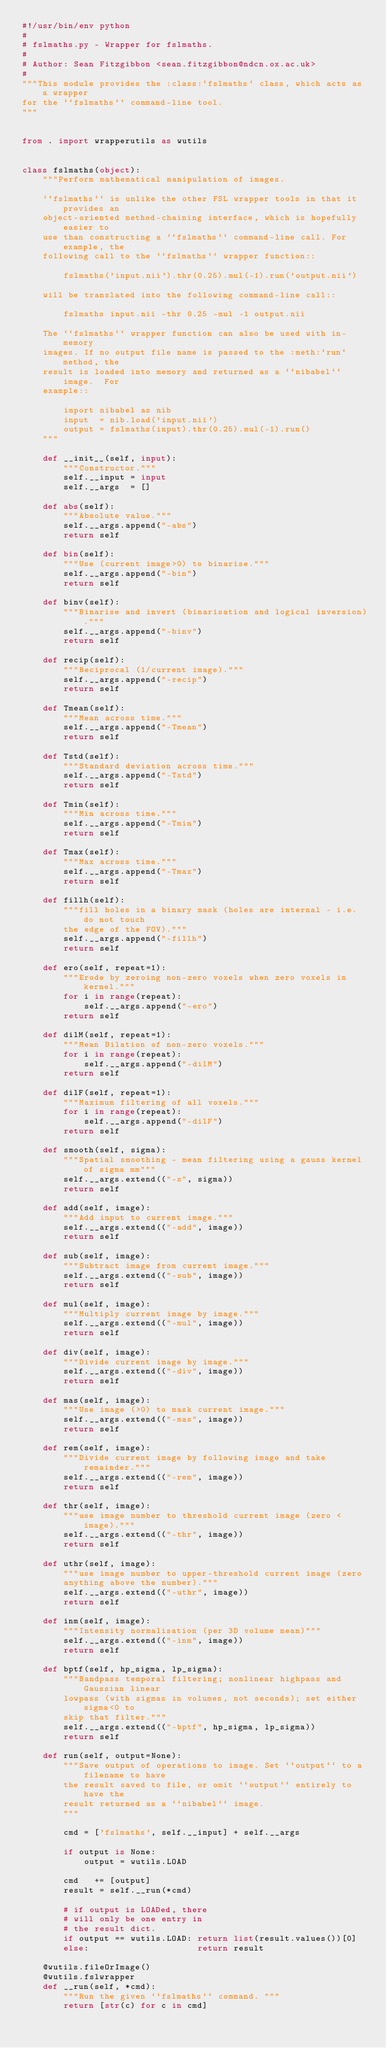Convert code to text. <code><loc_0><loc_0><loc_500><loc_500><_Python_>#!/usr/bin/env python
#
# fslmaths.py - Wrapper for fslmaths.
#
# Author: Sean Fitzgibbon <sean.fitzgibbon@ndcn.ox.ac.uk>
#
"""This module provides the :class:`fslmaths` class, which acts as a wrapper
for the ``fslmaths`` command-line tool.
"""


from . import wrapperutils as wutils


class fslmaths(object):
    """Perform mathematical manipulation of images.

    ``fslmaths`` is unlike the other FSL wrapper tools in that it provides an
    object-oriented method-chaining interface, which is hopefully easier to
    use than constructing a ``fslmaths`` command-line call. For example, the
    following call to the ``fslmaths`` wrapper function::

        fslmaths('input.nii').thr(0.25).mul(-1).run('output.nii')

    will be translated into the following command-line call::

        fslmaths input.nii -thr 0.25 -mul -1 output.nii

    The ``fslmaths`` wrapper function can also be used with in-memory
    images. If no output file name is passed to the :meth:`run` method, the
    result is loaded into memory and returned as a ``nibabel`` image.  For
    example::

        import nibabel as nib
        input  = nib.load('input.nii')
        output = fslmaths(input).thr(0.25).mul(-1).run()
    """

    def __init__(self, input):
        """Constructor."""
        self.__input = input
        self.__args  = []

    def abs(self):
        """Absolute value."""
        self.__args.append("-abs")
        return self

    def bin(self):
        """Use (current image>0) to binarise."""
        self.__args.append("-bin")
        return self

    def binv(self):
        """Binarise and invert (binarisation and logical inversion)."""
        self.__args.append("-binv")
        return self

    def recip(self):
        """Reciprocal (1/current image)."""
        self.__args.append("-recip")
        return self

    def Tmean(self):
        """Mean across time."""
        self.__args.append("-Tmean")
        return self

    def Tstd(self):
        """Standard deviation across time."""
        self.__args.append("-Tstd")
        return self

    def Tmin(self):
        """Min across time."""
        self.__args.append("-Tmin")
        return self

    def Tmax(self):
        """Max across time."""
        self.__args.append("-Tmax")
        return self

    def fillh(self):
        """fill holes in a binary mask (holes are internal - i.e. do not touch
        the edge of the FOV)."""
        self.__args.append("-fillh")
        return self

    def ero(self, repeat=1):
        """Erode by zeroing non-zero voxels when zero voxels in kernel."""
        for i in range(repeat):
            self.__args.append("-ero")
        return self

    def dilM(self, repeat=1):
        """Mean Dilation of non-zero voxels."""
        for i in range(repeat):
            self.__args.append("-dilM")
        return self

    def dilF(self, repeat=1):
        """Maximum filtering of all voxels."""
        for i in range(repeat):
            self.__args.append("-dilF")
        return self

    def smooth(self, sigma):
        """Spatial smoothing - mean filtering using a gauss kernel of sigma mm"""
        self.__args.extend(("-s", sigma))
        return self

    def add(self, image):
        """Add input to current image."""
        self.__args.extend(("-add", image))
        return self

    def sub(self, image):
        """Subtract image from current image."""
        self.__args.extend(("-sub", image))
        return self

    def mul(self, image):
        """Multiply current image by image."""
        self.__args.extend(("-mul", image))
        return self

    def div(self, image):
        """Divide current image by image."""
        self.__args.extend(("-div", image))
        return self

    def mas(self, image):
        """Use image (>0) to mask current image."""
        self.__args.extend(("-mas", image))
        return self

    def rem(self, image):
        """Divide current image by following image and take remainder."""
        self.__args.extend(("-rem", image))
        return self

    def thr(self, image):
        """use image number to threshold current image (zero < image)."""
        self.__args.extend(("-thr", image))
        return self

    def uthr(self, image):
        """use image number to upper-threshold current image (zero
        anything above the number)."""
        self.__args.extend(("-uthr", image))
        return self

    def inm(self, image):
        """Intensity normalisation (per 3D volume mean)"""
        self.__args.extend(("-inm", image))
        return self

    def bptf(self, hp_sigma, lp_sigma):
        """Bandpass temporal filtering; nonlinear highpass and Gaussian linear
        lowpass (with sigmas in volumes, not seconds); set either sigma<0 to
        skip that filter."""
        self.__args.extend(("-bptf", hp_sigma, lp_sigma))
        return self

    def run(self, output=None):
        """Save output of operations to image. Set ``output`` to a filename to have
        the result saved to file, or omit ``output`` entirely to have the
        result returned as a ``nibabel`` image.
        """

        cmd = ['fslmaths', self.__input] + self.__args

        if output is None:
            output = wutils.LOAD

        cmd   += [output]
        result = self.__run(*cmd)

        # if output is LOADed, there
        # will only be one entry in
        # the result dict.
        if output == wutils.LOAD: return list(result.values())[0]
        else:                     return result

    @wutils.fileOrImage()
    @wutils.fslwrapper
    def __run(self, *cmd):
        """Run the given ``fslmaths`` command. """
        return [str(c) for c in cmd]
</code> 